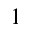<formula> <loc_0><loc_0><loc_500><loc_500>^ { 1 }</formula> 